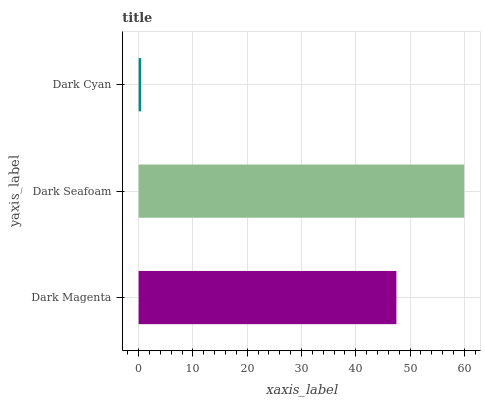Is Dark Cyan the minimum?
Answer yes or no. Yes. Is Dark Seafoam the maximum?
Answer yes or no. Yes. Is Dark Seafoam the minimum?
Answer yes or no. No. Is Dark Cyan the maximum?
Answer yes or no. No. Is Dark Seafoam greater than Dark Cyan?
Answer yes or no. Yes. Is Dark Cyan less than Dark Seafoam?
Answer yes or no. Yes. Is Dark Cyan greater than Dark Seafoam?
Answer yes or no. No. Is Dark Seafoam less than Dark Cyan?
Answer yes or no. No. Is Dark Magenta the high median?
Answer yes or no. Yes. Is Dark Magenta the low median?
Answer yes or no. Yes. Is Dark Cyan the high median?
Answer yes or no. No. Is Dark Cyan the low median?
Answer yes or no. No. 